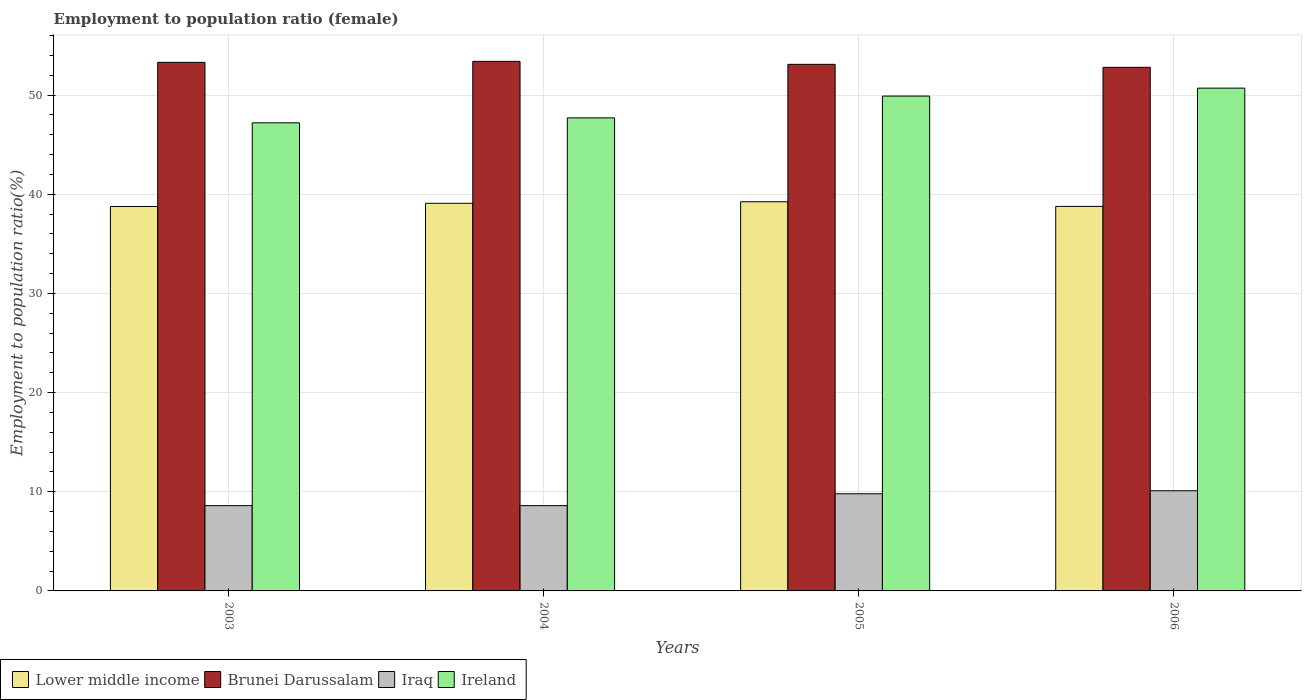How many groups of bars are there?
Give a very brief answer. 4. Are the number of bars on each tick of the X-axis equal?
Your response must be concise. Yes. How many bars are there on the 2nd tick from the left?
Give a very brief answer. 4. How many bars are there on the 4th tick from the right?
Provide a short and direct response. 4. What is the label of the 3rd group of bars from the left?
Your answer should be very brief. 2005. In how many cases, is the number of bars for a given year not equal to the number of legend labels?
Your response must be concise. 0. What is the employment to population ratio in Brunei Darussalam in 2004?
Offer a terse response. 53.4. Across all years, what is the maximum employment to population ratio in Ireland?
Your answer should be compact. 50.7. Across all years, what is the minimum employment to population ratio in Ireland?
Your answer should be very brief. 47.2. In which year was the employment to population ratio in Lower middle income minimum?
Your response must be concise. 2003. What is the total employment to population ratio in Ireland in the graph?
Ensure brevity in your answer.  195.5. What is the difference between the employment to population ratio in Ireland in 2003 and that in 2004?
Provide a succinct answer. -0.5. What is the difference between the employment to population ratio in Brunei Darussalam in 2005 and the employment to population ratio in Iraq in 2006?
Give a very brief answer. 43. What is the average employment to population ratio in Ireland per year?
Offer a very short reply. 48.88. In the year 2004, what is the difference between the employment to population ratio in Brunei Darussalam and employment to population ratio in Ireland?
Your answer should be compact. 5.7. What is the ratio of the employment to population ratio in Lower middle income in 2003 to that in 2006?
Your response must be concise. 1. What is the difference between the highest and the second highest employment to population ratio in Brunei Darussalam?
Give a very brief answer. 0.1. What is the difference between the highest and the lowest employment to population ratio in Iraq?
Make the answer very short. 1.5. Is the sum of the employment to population ratio in Lower middle income in 2003 and 2006 greater than the maximum employment to population ratio in Ireland across all years?
Your response must be concise. Yes. What does the 1st bar from the left in 2004 represents?
Ensure brevity in your answer.  Lower middle income. What does the 2nd bar from the right in 2003 represents?
Ensure brevity in your answer.  Iraq. How many years are there in the graph?
Give a very brief answer. 4. What is the difference between two consecutive major ticks on the Y-axis?
Provide a succinct answer. 10. Are the values on the major ticks of Y-axis written in scientific E-notation?
Offer a very short reply. No. Does the graph contain any zero values?
Ensure brevity in your answer.  No. Where does the legend appear in the graph?
Provide a short and direct response. Bottom left. What is the title of the graph?
Provide a succinct answer. Employment to population ratio (female). Does "Cote d'Ivoire" appear as one of the legend labels in the graph?
Give a very brief answer. No. What is the label or title of the X-axis?
Your response must be concise. Years. What is the label or title of the Y-axis?
Ensure brevity in your answer.  Employment to population ratio(%). What is the Employment to population ratio(%) of Lower middle income in 2003?
Offer a very short reply. 38.76. What is the Employment to population ratio(%) in Brunei Darussalam in 2003?
Offer a terse response. 53.3. What is the Employment to population ratio(%) in Iraq in 2003?
Provide a short and direct response. 8.6. What is the Employment to population ratio(%) of Ireland in 2003?
Offer a terse response. 47.2. What is the Employment to population ratio(%) of Lower middle income in 2004?
Ensure brevity in your answer.  39.09. What is the Employment to population ratio(%) of Brunei Darussalam in 2004?
Provide a short and direct response. 53.4. What is the Employment to population ratio(%) in Iraq in 2004?
Make the answer very short. 8.6. What is the Employment to population ratio(%) in Ireland in 2004?
Provide a succinct answer. 47.7. What is the Employment to population ratio(%) of Lower middle income in 2005?
Your response must be concise. 39.24. What is the Employment to population ratio(%) of Brunei Darussalam in 2005?
Your response must be concise. 53.1. What is the Employment to population ratio(%) in Iraq in 2005?
Make the answer very short. 9.8. What is the Employment to population ratio(%) of Ireland in 2005?
Your answer should be very brief. 49.9. What is the Employment to population ratio(%) in Lower middle income in 2006?
Provide a succinct answer. 38.77. What is the Employment to population ratio(%) of Brunei Darussalam in 2006?
Provide a short and direct response. 52.8. What is the Employment to population ratio(%) in Iraq in 2006?
Your answer should be compact. 10.1. What is the Employment to population ratio(%) in Ireland in 2006?
Your answer should be compact. 50.7. Across all years, what is the maximum Employment to population ratio(%) of Lower middle income?
Your response must be concise. 39.24. Across all years, what is the maximum Employment to population ratio(%) in Brunei Darussalam?
Give a very brief answer. 53.4. Across all years, what is the maximum Employment to population ratio(%) of Iraq?
Your answer should be compact. 10.1. Across all years, what is the maximum Employment to population ratio(%) in Ireland?
Provide a succinct answer. 50.7. Across all years, what is the minimum Employment to population ratio(%) of Lower middle income?
Your response must be concise. 38.76. Across all years, what is the minimum Employment to population ratio(%) in Brunei Darussalam?
Keep it short and to the point. 52.8. Across all years, what is the minimum Employment to population ratio(%) of Iraq?
Provide a short and direct response. 8.6. Across all years, what is the minimum Employment to population ratio(%) in Ireland?
Your answer should be compact. 47.2. What is the total Employment to population ratio(%) in Lower middle income in the graph?
Give a very brief answer. 155.87. What is the total Employment to population ratio(%) in Brunei Darussalam in the graph?
Make the answer very short. 212.6. What is the total Employment to population ratio(%) of Iraq in the graph?
Ensure brevity in your answer.  37.1. What is the total Employment to population ratio(%) of Ireland in the graph?
Provide a succinct answer. 195.5. What is the difference between the Employment to population ratio(%) in Lower middle income in 2003 and that in 2004?
Your answer should be compact. -0.32. What is the difference between the Employment to population ratio(%) in Brunei Darussalam in 2003 and that in 2004?
Provide a short and direct response. -0.1. What is the difference between the Employment to population ratio(%) in Ireland in 2003 and that in 2004?
Provide a succinct answer. -0.5. What is the difference between the Employment to population ratio(%) in Lower middle income in 2003 and that in 2005?
Ensure brevity in your answer.  -0.48. What is the difference between the Employment to population ratio(%) in Brunei Darussalam in 2003 and that in 2005?
Your answer should be very brief. 0.2. What is the difference between the Employment to population ratio(%) of Iraq in 2003 and that in 2005?
Make the answer very short. -1.2. What is the difference between the Employment to population ratio(%) in Lower middle income in 2003 and that in 2006?
Keep it short and to the point. -0.01. What is the difference between the Employment to population ratio(%) of Brunei Darussalam in 2003 and that in 2006?
Offer a very short reply. 0.5. What is the difference between the Employment to population ratio(%) in Lower middle income in 2004 and that in 2005?
Your answer should be compact. -0.16. What is the difference between the Employment to population ratio(%) of Ireland in 2004 and that in 2005?
Provide a short and direct response. -2.2. What is the difference between the Employment to population ratio(%) of Lower middle income in 2004 and that in 2006?
Offer a terse response. 0.31. What is the difference between the Employment to population ratio(%) of Lower middle income in 2005 and that in 2006?
Provide a succinct answer. 0.47. What is the difference between the Employment to population ratio(%) in Iraq in 2005 and that in 2006?
Provide a short and direct response. -0.3. What is the difference between the Employment to population ratio(%) of Ireland in 2005 and that in 2006?
Keep it short and to the point. -0.8. What is the difference between the Employment to population ratio(%) of Lower middle income in 2003 and the Employment to population ratio(%) of Brunei Darussalam in 2004?
Provide a succinct answer. -14.64. What is the difference between the Employment to population ratio(%) of Lower middle income in 2003 and the Employment to population ratio(%) of Iraq in 2004?
Your answer should be very brief. 30.16. What is the difference between the Employment to population ratio(%) of Lower middle income in 2003 and the Employment to population ratio(%) of Ireland in 2004?
Ensure brevity in your answer.  -8.94. What is the difference between the Employment to population ratio(%) in Brunei Darussalam in 2003 and the Employment to population ratio(%) in Iraq in 2004?
Offer a terse response. 44.7. What is the difference between the Employment to population ratio(%) of Brunei Darussalam in 2003 and the Employment to population ratio(%) of Ireland in 2004?
Offer a very short reply. 5.6. What is the difference between the Employment to population ratio(%) of Iraq in 2003 and the Employment to population ratio(%) of Ireland in 2004?
Provide a short and direct response. -39.1. What is the difference between the Employment to population ratio(%) in Lower middle income in 2003 and the Employment to population ratio(%) in Brunei Darussalam in 2005?
Ensure brevity in your answer.  -14.34. What is the difference between the Employment to population ratio(%) in Lower middle income in 2003 and the Employment to population ratio(%) in Iraq in 2005?
Offer a very short reply. 28.96. What is the difference between the Employment to population ratio(%) in Lower middle income in 2003 and the Employment to population ratio(%) in Ireland in 2005?
Give a very brief answer. -11.14. What is the difference between the Employment to population ratio(%) in Brunei Darussalam in 2003 and the Employment to population ratio(%) in Iraq in 2005?
Offer a very short reply. 43.5. What is the difference between the Employment to population ratio(%) in Brunei Darussalam in 2003 and the Employment to population ratio(%) in Ireland in 2005?
Your response must be concise. 3.4. What is the difference between the Employment to population ratio(%) of Iraq in 2003 and the Employment to population ratio(%) of Ireland in 2005?
Ensure brevity in your answer.  -41.3. What is the difference between the Employment to population ratio(%) of Lower middle income in 2003 and the Employment to population ratio(%) of Brunei Darussalam in 2006?
Make the answer very short. -14.04. What is the difference between the Employment to population ratio(%) in Lower middle income in 2003 and the Employment to population ratio(%) in Iraq in 2006?
Your answer should be very brief. 28.66. What is the difference between the Employment to population ratio(%) of Lower middle income in 2003 and the Employment to population ratio(%) of Ireland in 2006?
Your answer should be compact. -11.94. What is the difference between the Employment to population ratio(%) in Brunei Darussalam in 2003 and the Employment to population ratio(%) in Iraq in 2006?
Give a very brief answer. 43.2. What is the difference between the Employment to population ratio(%) of Brunei Darussalam in 2003 and the Employment to population ratio(%) of Ireland in 2006?
Provide a short and direct response. 2.6. What is the difference between the Employment to population ratio(%) in Iraq in 2003 and the Employment to population ratio(%) in Ireland in 2006?
Your response must be concise. -42.1. What is the difference between the Employment to population ratio(%) in Lower middle income in 2004 and the Employment to population ratio(%) in Brunei Darussalam in 2005?
Ensure brevity in your answer.  -14.01. What is the difference between the Employment to population ratio(%) in Lower middle income in 2004 and the Employment to population ratio(%) in Iraq in 2005?
Make the answer very short. 29.29. What is the difference between the Employment to population ratio(%) in Lower middle income in 2004 and the Employment to population ratio(%) in Ireland in 2005?
Keep it short and to the point. -10.81. What is the difference between the Employment to population ratio(%) in Brunei Darussalam in 2004 and the Employment to population ratio(%) in Iraq in 2005?
Offer a very short reply. 43.6. What is the difference between the Employment to population ratio(%) in Iraq in 2004 and the Employment to population ratio(%) in Ireland in 2005?
Keep it short and to the point. -41.3. What is the difference between the Employment to population ratio(%) in Lower middle income in 2004 and the Employment to population ratio(%) in Brunei Darussalam in 2006?
Keep it short and to the point. -13.71. What is the difference between the Employment to population ratio(%) in Lower middle income in 2004 and the Employment to population ratio(%) in Iraq in 2006?
Keep it short and to the point. 28.99. What is the difference between the Employment to population ratio(%) in Lower middle income in 2004 and the Employment to population ratio(%) in Ireland in 2006?
Offer a terse response. -11.61. What is the difference between the Employment to population ratio(%) of Brunei Darussalam in 2004 and the Employment to population ratio(%) of Iraq in 2006?
Offer a terse response. 43.3. What is the difference between the Employment to population ratio(%) in Brunei Darussalam in 2004 and the Employment to population ratio(%) in Ireland in 2006?
Offer a terse response. 2.7. What is the difference between the Employment to population ratio(%) of Iraq in 2004 and the Employment to population ratio(%) of Ireland in 2006?
Offer a terse response. -42.1. What is the difference between the Employment to population ratio(%) in Lower middle income in 2005 and the Employment to population ratio(%) in Brunei Darussalam in 2006?
Offer a terse response. -13.56. What is the difference between the Employment to population ratio(%) in Lower middle income in 2005 and the Employment to population ratio(%) in Iraq in 2006?
Your answer should be compact. 29.14. What is the difference between the Employment to population ratio(%) in Lower middle income in 2005 and the Employment to population ratio(%) in Ireland in 2006?
Your answer should be compact. -11.46. What is the difference between the Employment to population ratio(%) of Iraq in 2005 and the Employment to population ratio(%) of Ireland in 2006?
Provide a short and direct response. -40.9. What is the average Employment to population ratio(%) in Lower middle income per year?
Give a very brief answer. 38.97. What is the average Employment to population ratio(%) in Brunei Darussalam per year?
Provide a short and direct response. 53.15. What is the average Employment to population ratio(%) of Iraq per year?
Provide a short and direct response. 9.28. What is the average Employment to population ratio(%) in Ireland per year?
Offer a terse response. 48.88. In the year 2003, what is the difference between the Employment to population ratio(%) of Lower middle income and Employment to population ratio(%) of Brunei Darussalam?
Offer a terse response. -14.54. In the year 2003, what is the difference between the Employment to population ratio(%) in Lower middle income and Employment to population ratio(%) in Iraq?
Offer a very short reply. 30.16. In the year 2003, what is the difference between the Employment to population ratio(%) of Lower middle income and Employment to population ratio(%) of Ireland?
Give a very brief answer. -8.44. In the year 2003, what is the difference between the Employment to population ratio(%) of Brunei Darussalam and Employment to population ratio(%) of Iraq?
Your answer should be compact. 44.7. In the year 2003, what is the difference between the Employment to population ratio(%) of Iraq and Employment to population ratio(%) of Ireland?
Ensure brevity in your answer.  -38.6. In the year 2004, what is the difference between the Employment to population ratio(%) of Lower middle income and Employment to population ratio(%) of Brunei Darussalam?
Ensure brevity in your answer.  -14.31. In the year 2004, what is the difference between the Employment to population ratio(%) of Lower middle income and Employment to population ratio(%) of Iraq?
Ensure brevity in your answer.  30.49. In the year 2004, what is the difference between the Employment to population ratio(%) of Lower middle income and Employment to population ratio(%) of Ireland?
Provide a succinct answer. -8.61. In the year 2004, what is the difference between the Employment to population ratio(%) in Brunei Darussalam and Employment to population ratio(%) in Iraq?
Your answer should be very brief. 44.8. In the year 2004, what is the difference between the Employment to population ratio(%) of Brunei Darussalam and Employment to population ratio(%) of Ireland?
Your response must be concise. 5.7. In the year 2004, what is the difference between the Employment to population ratio(%) of Iraq and Employment to population ratio(%) of Ireland?
Offer a very short reply. -39.1. In the year 2005, what is the difference between the Employment to population ratio(%) of Lower middle income and Employment to population ratio(%) of Brunei Darussalam?
Your answer should be very brief. -13.86. In the year 2005, what is the difference between the Employment to population ratio(%) of Lower middle income and Employment to population ratio(%) of Iraq?
Provide a short and direct response. 29.44. In the year 2005, what is the difference between the Employment to population ratio(%) of Lower middle income and Employment to population ratio(%) of Ireland?
Provide a short and direct response. -10.66. In the year 2005, what is the difference between the Employment to population ratio(%) of Brunei Darussalam and Employment to population ratio(%) of Iraq?
Make the answer very short. 43.3. In the year 2005, what is the difference between the Employment to population ratio(%) of Iraq and Employment to population ratio(%) of Ireland?
Your response must be concise. -40.1. In the year 2006, what is the difference between the Employment to population ratio(%) of Lower middle income and Employment to population ratio(%) of Brunei Darussalam?
Give a very brief answer. -14.03. In the year 2006, what is the difference between the Employment to population ratio(%) of Lower middle income and Employment to population ratio(%) of Iraq?
Provide a succinct answer. 28.67. In the year 2006, what is the difference between the Employment to population ratio(%) of Lower middle income and Employment to population ratio(%) of Ireland?
Ensure brevity in your answer.  -11.93. In the year 2006, what is the difference between the Employment to population ratio(%) of Brunei Darussalam and Employment to population ratio(%) of Iraq?
Your response must be concise. 42.7. In the year 2006, what is the difference between the Employment to population ratio(%) in Brunei Darussalam and Employment to population ratio(%) in Ireland?
Your answer should be compact. 2.1. In the year 2006, what is the difference between the Employment to population ratio(%) in Iraq and Employment to population ratio(%) in Ireland?
Your answer should be very brief. -40.6. What is the ratio of the Employment to population ratio(%) of Brunei Darussalam in 2003 to that in 2004?
Give a very brief answer. 1. What is the ratio of the Employment to population ratio(%) of Iraq in 2003 to that in 2004?
Your answer should be compact. 1. What is the ratio of the Employment to population ratio(%) in Iraq in 2003 to that in 2005?
Offer a very short reply. 0.88. What is the ratio of the Employment to population ratio(%) in Ireland in 2003 to that in 2005?
Make the answer very short. 0.95. What is the ratio of the Employment to population ratio(%) in Brunei Darussalam in 2003 to that in 2006?
Keep it short and to the point. 1.01. What is the ratio of the Employment to population ratio(%) of Iraq in 2003 to that in 2006?
Your answer should be very brief. 0.85. What is the ratio of the Employment to population ratio(%) of Ireland in 2003 to that in 2006?
Provide a short and direct response. 0.93. What is the ratio of the Employment to population ratio(%) in Lower middle income in 2004 to that in 2005?
Give a very brief answer. 1. What is the ratio of the Employment to population ratio(%) in Brunei Darussalam in 2004 to that in 2005?
Keep it short and to the point. 1.01. What is the ratio of the Employment to population ratio(%) of Iraq in 2004 to that in 2005?
Ensure brevity in your answer.  0.88. What is the ratio of the Employment to population ratio(%) of Ireland in 2004 to that in 2005?
Ensure brevity in your answer.  0.96. What is the ratio of the Employment to population ratio(%) of Brunei Darussalam in 2004 to that in 2006?
Your answer should be very brief. 1.01. What is the ratio of the Employment to population ratio(%) in Iraq in 2004 to that in 2006?
Provide a succinct answer. 0.85. What is the ratio of the Employment to population ratio(%) of Ireland in 2004 to that in 2006?
Ensure brevity in your answer.  0.94. What is the ratio of the Employment to population ratio(%) of Lower middle income in 2005 to that in 2006?
Offer a terse response. 1.01. What is the ratio of the Employment to population ratio(%) of Brunei Darussalam in 2005 to that in 2006?
Ensure brevity in your answer.  1.01. What is the ratio of the Employment to population ratio(%) of Iraq in 2005 to that in 2006?
Your response must be concise. 0.97. What is the ratio of the Employment to population ratio(%) of Ireland in 2005 to that in 2006?
Offer a very short reply. 0.98. What is the difference between the highest and the second highest Employment to population ratio(%) in Lower middle income?
Your answer should be very brief. 0.16. What is the difference between the highest and the lowest Employment to population ratio(%) of Lower middle income?
Make the answer very short. 0.48. What is the difference between the highest and the lowest Employment to population ratio(%) in Iraq?
Offer a terse response. 1.5. 